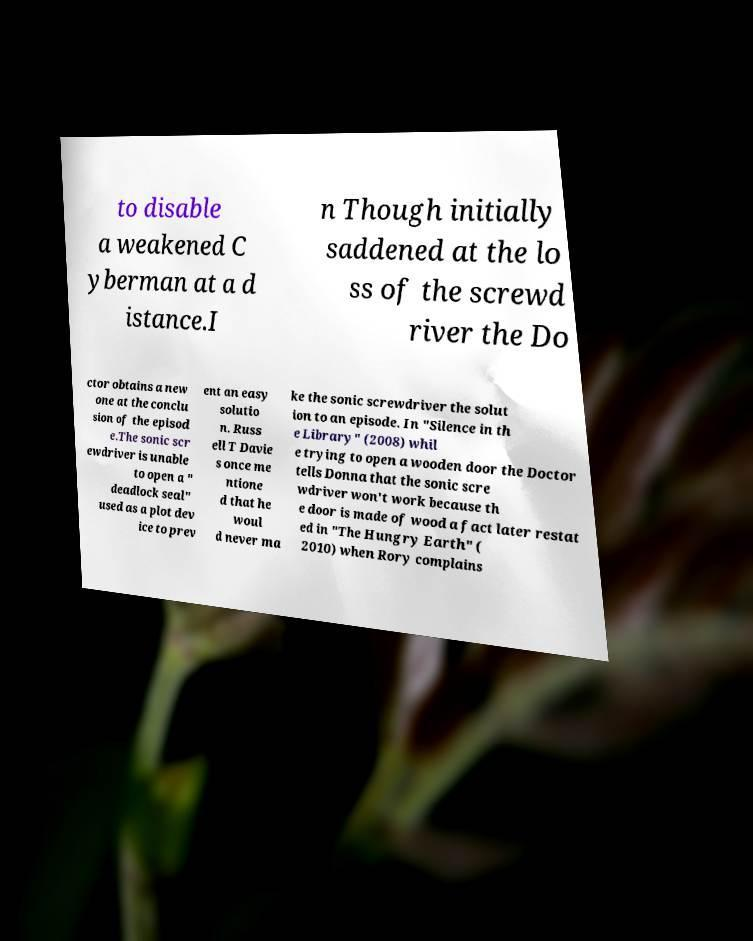I need the written content from this picture converted into text. Can you do that? to disable a weakened C yberman at a d istance.I n Though initially saddened at the lo ss of the screwd river the Do ctor obtains a new one at the conclu sion of the episod e.The sonic scr ewdriver is unable to open a " deadlock seal" used as a plot dev ice to prev ent an easy solutio n. Russ ell T Davie s once me ntione d that he woul d never ma ke the sonic screwdriver the solut ion to an episode. In "Silence in th e Library" (2008) whil e trying to open a wooden door the Doctor tells Donna that the sonic scre wdriver won't work because th e door is made of wood a fact later restat ed in "The Hungry Earth" ( 2010) when Rory complains 